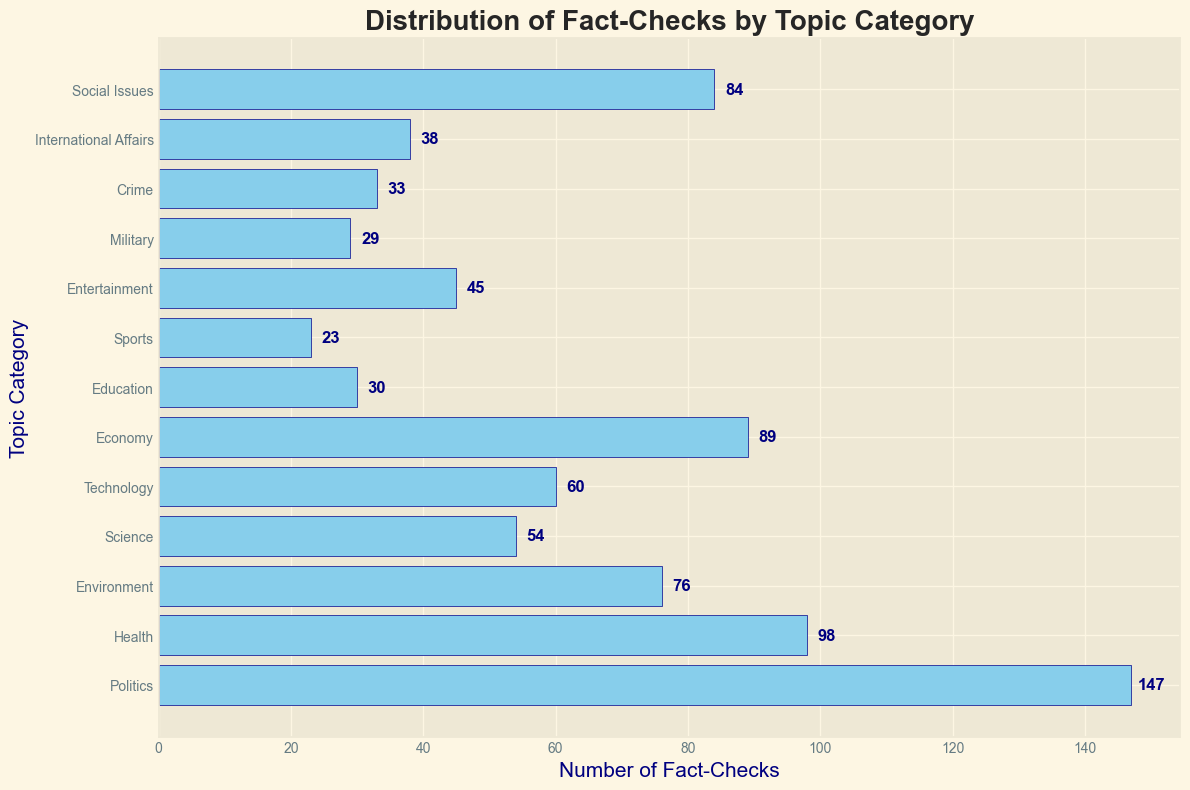Which topic category has the highest number of fact-checks? The bar with the greatest length represents the topic category with the highest number of fact-checks.
Answer: Politics What is the total number of fact-checks in the categories of Health, Environment, and Science? Add the number of fact-checks for Health (98), Environment (76), and Science (54). The total is 98 + 76 + 54.
Answer: 228 How many more fact-checks are there for Politics compared to Technology? Subtract the number of fact-checks for Technology (60) from the number of fact-checks for Politics (147).
Answer: 87 Which category has fewer fact-checks: Crime or International Affairs? Compare the number of fact-checks for Crime (33) and International Affairs (38). Crime has fewer fact-checks.
Answer: Crime What is the average number of fact-checks for the categories of Economy, Education, and Military? Find the average by adding the number of fact-checks for Economy (89), Education (30), and Military (29), then divide by 3. The average is (89 + 30 + 29) / 3.
Answer: 49.33 Which category has the second-highest number of fact-checks? Identify the category with the second longest bar after Politics.
Answer: Health Is the number of fact-checks for Social Issues greater than for Science and Technology combined? Add the number of fact-checks for Science (54) and Technology (60), then compare to Social Issues (84). The combined sum is 54 + 60 = 114, which is greater than 84.
Answer: No How many categories have more than 50 fact-checks? Count the bars with a length corresponding to more than 50 fact-checks. These categories are Politics, Health, Environment, Technology, Economy, Science, Social Issues.
Answer: 7 What is the difference between the number of fact-checks in Entertainment and Sports? Subtract the number of fact-checks for Sports (23) from Entertainment (45).
Answer: 22 What is the proportion of fact-checks in the Politics category relative to the total number of fact-checks across all categories? Sum the number of fact-checks across all categories, then divide the number of fact-checks for Politics (147) by this total. The sum is 756, so the proportion is 147 / 756.
Answer: 0.1946 